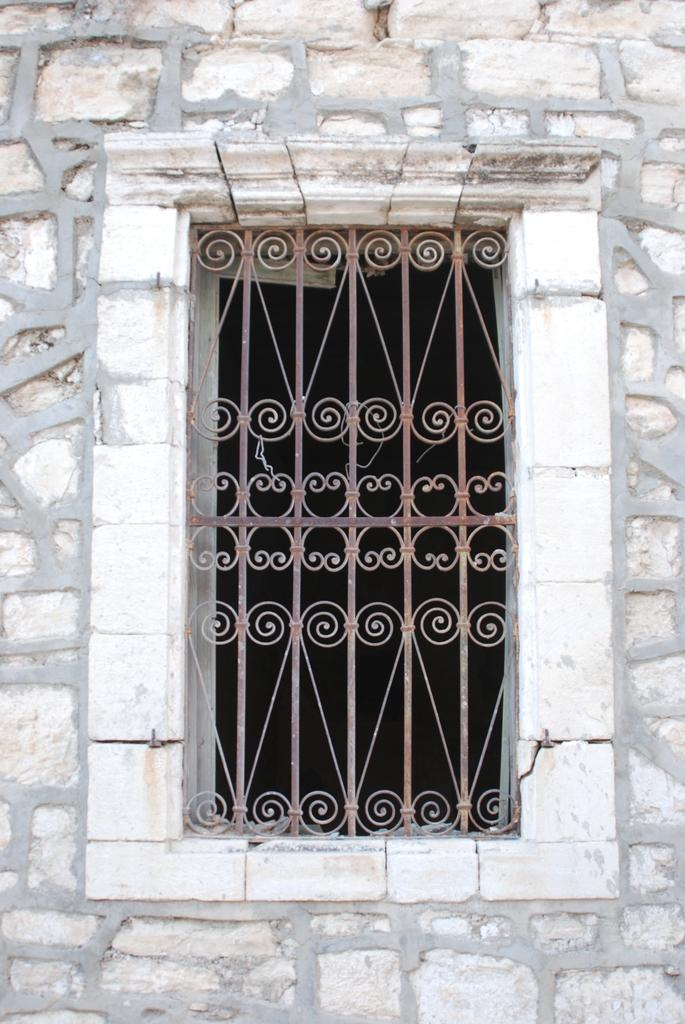What is present on a wall in the image? There is a window on a wall in the image. Can you describe the window in the image? The window is the main feature on the wall in the image. How many sisters are visible in the image? There are no sisters present in the image; it only features a window on a wall. What type of cub can be seen playing with the window in the image? There is no cub present in the image, and the window is not an object that a cub could play with. 